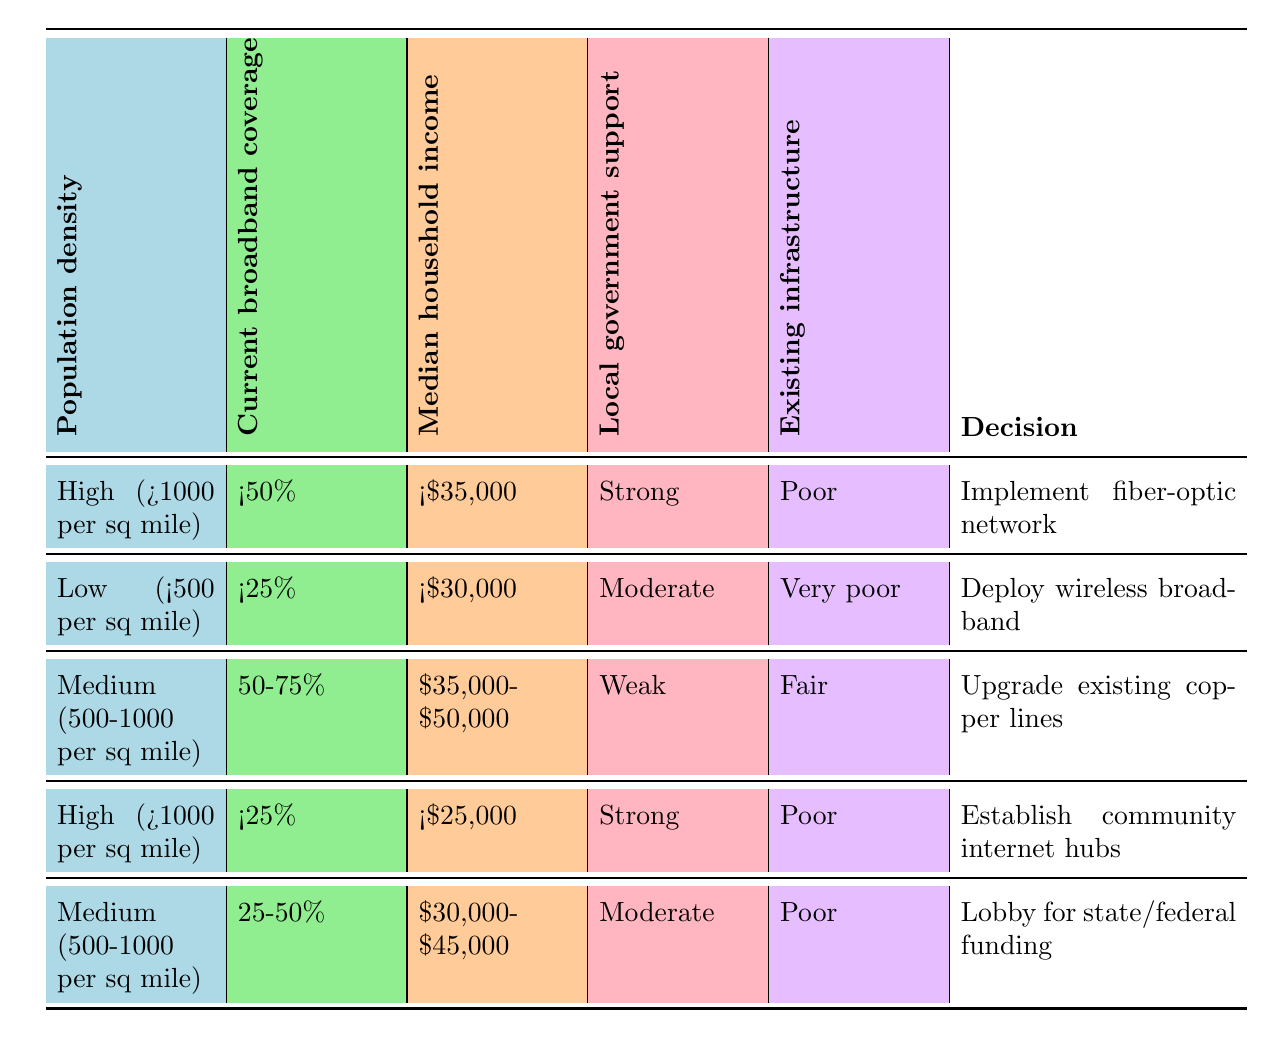What is the decision for areas with high population density and less than 50% broadband coverage? In the table, under the row where the population density is high (>1000 per sq mile) and the current broadband coverage is less than 50%, the decision is to implement a fiber-optic network.
Answer: Implement fiber-optic network Which income bracket is associated with establishing community internet hubs? Looking at the row for establishing community internet hubs, it specifies that the median household income should be less than $25,000.
Answer: Less than $25,000 Is there a decision to deploy wireless broadband in areas with a low population density? In the table, there is a rule stating that if the population density is low (<500 per sq mile) and the current broadband coverage is less than 25%, the decision is to deploy wireless broadband. Since both conditions are met, the answer is yes.
Answer: Yes How many decisions suggest lobbying for state or federal funding? The table indicates one specific decision has been labeled as lobbying for state or federal funding, which applies to areas with medium population density (500-1000 per sq mile) and 25-50% current broadband coverage.
Answer: One decision What is the common factor among the areas that suggest upgrading existing copper lines? The table shows that for upgrading existing copper lines, the common factors include a medium population density (500-1000 per sq mile), current broadband coverage of 50-75%, median household income of $35,000-$50,000, weak local government support, and fair existing infrastructure.
Answer: Medium population density with fair infrastructure What decision should be made for a high-density area with very poor existing infrastructure and strong local government support? The decision for a high-density area (>1000 per sq mile) with very poor existing infrastructure and strong local government support is to implement a fiber-optic network.
Answer: Implement fiber-optic network Are there any decisions related to areas with a median household income below $30,000? Yes, there are decisions for areas with income below $30,000. Specifically, one is to deploy wireless broadband for low-density areas and another decision to establish community internet hubs for high-density areas with very low income.
Answer: Yes What is the decision for areas with medium population density and a household income of $40,000? Referring to the table, an area with medium population density (500-1000 per sq mile) and a household income of $40,000 would align with the criteria for upgrading existing copper lines, as the income falls within the $35,000-$50,000 range.
Answer: Upgrade existing copper lines 